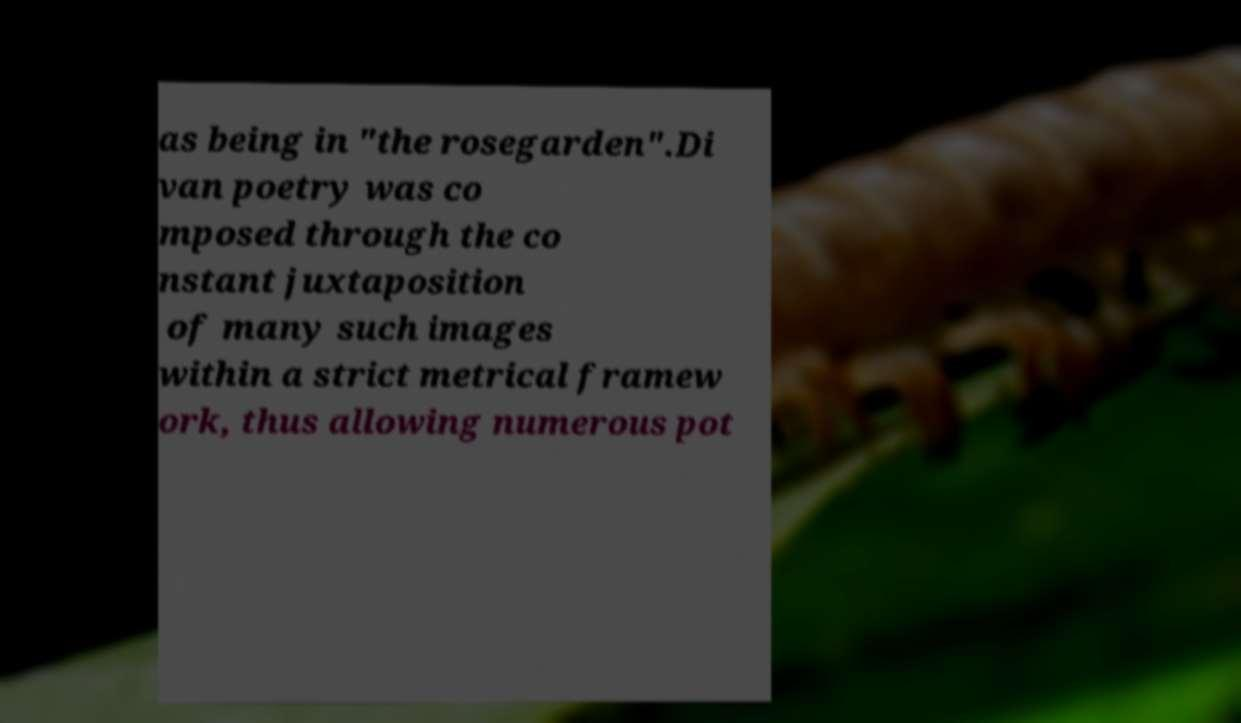Could you extract and type out the text from this image? as being in "the rosegarden".Di van poetry was co mposed through the co nstant juxtaposition of many such images within a strict metrical framew ork, thus allowing numerous pot 